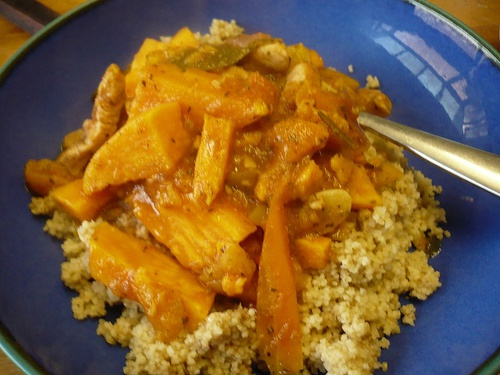Describe the objects in this image and their specific colors. I can see bowl in olive, orange, navy, blue, and black tones, carrot in black, red, orange, and maroon tones, carrot in black, orange, red, and maroon tones, carrot in black, orange, and red tones, and spoon in black, khaki, tan, ivory, and olive tones in this image. 